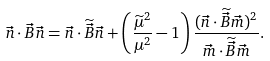<formula> <loc_0><loc_0><loc_500><loc_500>\vec { n } \cdot \vec { B } \vec { n } = \vec { n } \cdot \widetilde { \vec { B } } \vec { n } + \left ( \frac { \widetilde { \mu } ^ { 2 } } { \mu ^ { 2 } } - 1 \right ) \frac { ( \vec { n } \cdot \widetilde { \vec { B } } \vec { m } ) ^ { 2 } } { \vec { m } \cdot \widetilde { \vec { B } } \vec { m } } .</formula> 